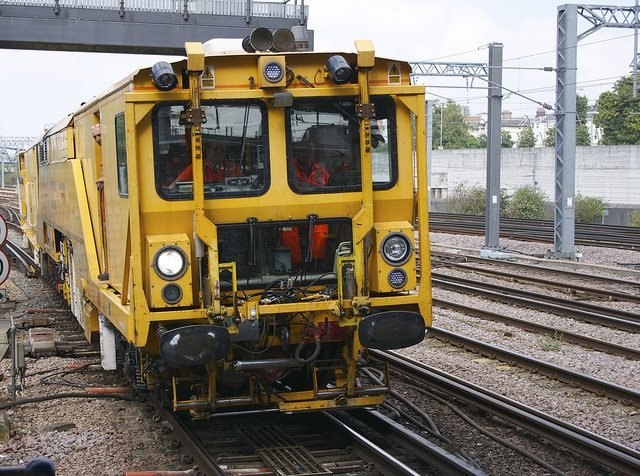Describe the objects in this image and their specific colors. I can see train in lavender, black, orange, tan, and gray tones, people in lavender, maroon, black, brown, and gray tones, and people in lavender, black, maroon, gray, and brown tones in this image. 